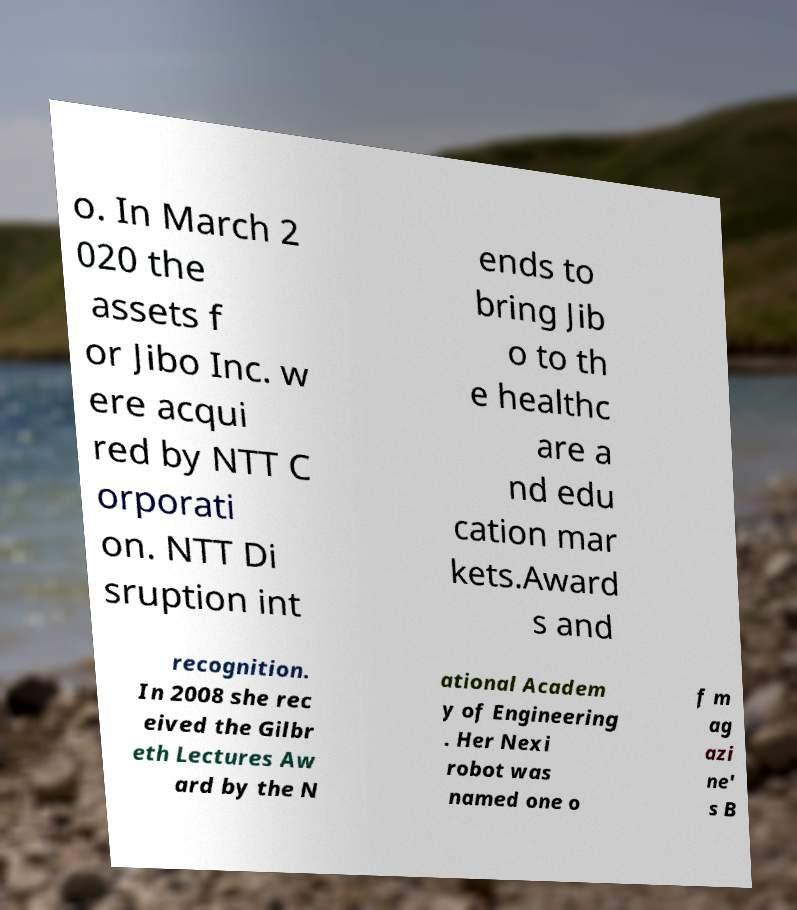Please identify and transcribe the text found in this image. o. In March 2 020 the assets f or Jibo Inc. w ere acqui red by NTT C orporati on. NTT Di sruption int ends to bring Jib o to th e healthc are a nd edu cation mar kets.Award s and recognition. In 2008 she rec eived the Gilbr eth Lectures Aw ard by the N ational Academ y of Engineering . Her Nexi robot was named one o f m ag azi ne' s B 